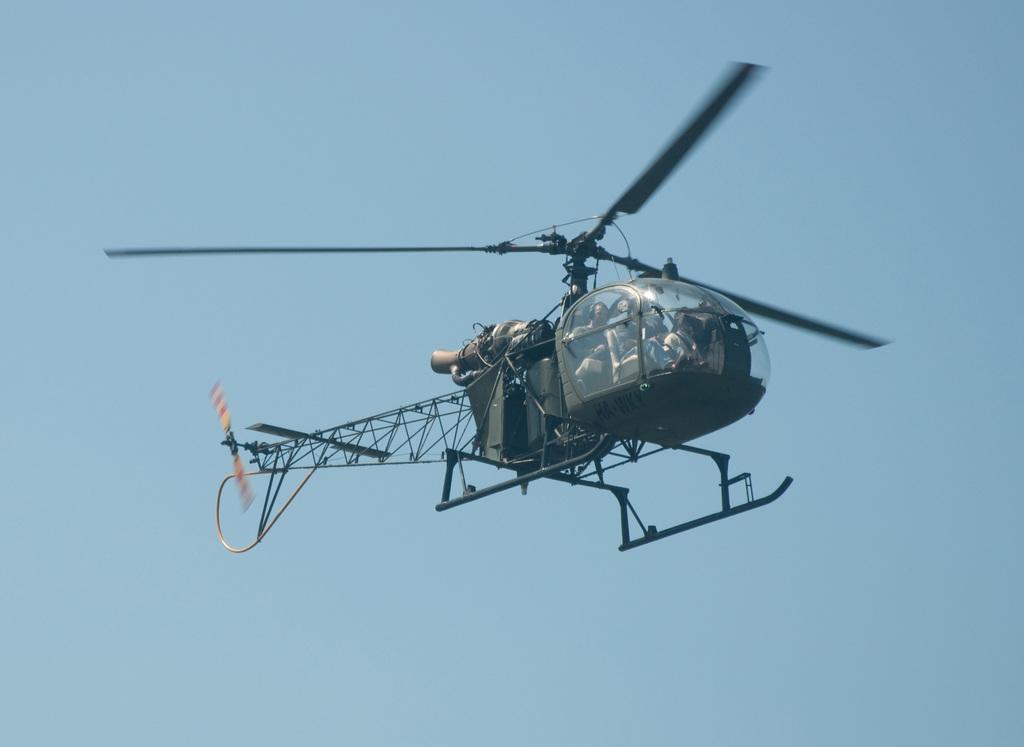How would you summarize this image in a sentence or two? In this picture we can see a helicopter flying in the air and we can see a person inside a helicopter. In the background there is sky. 